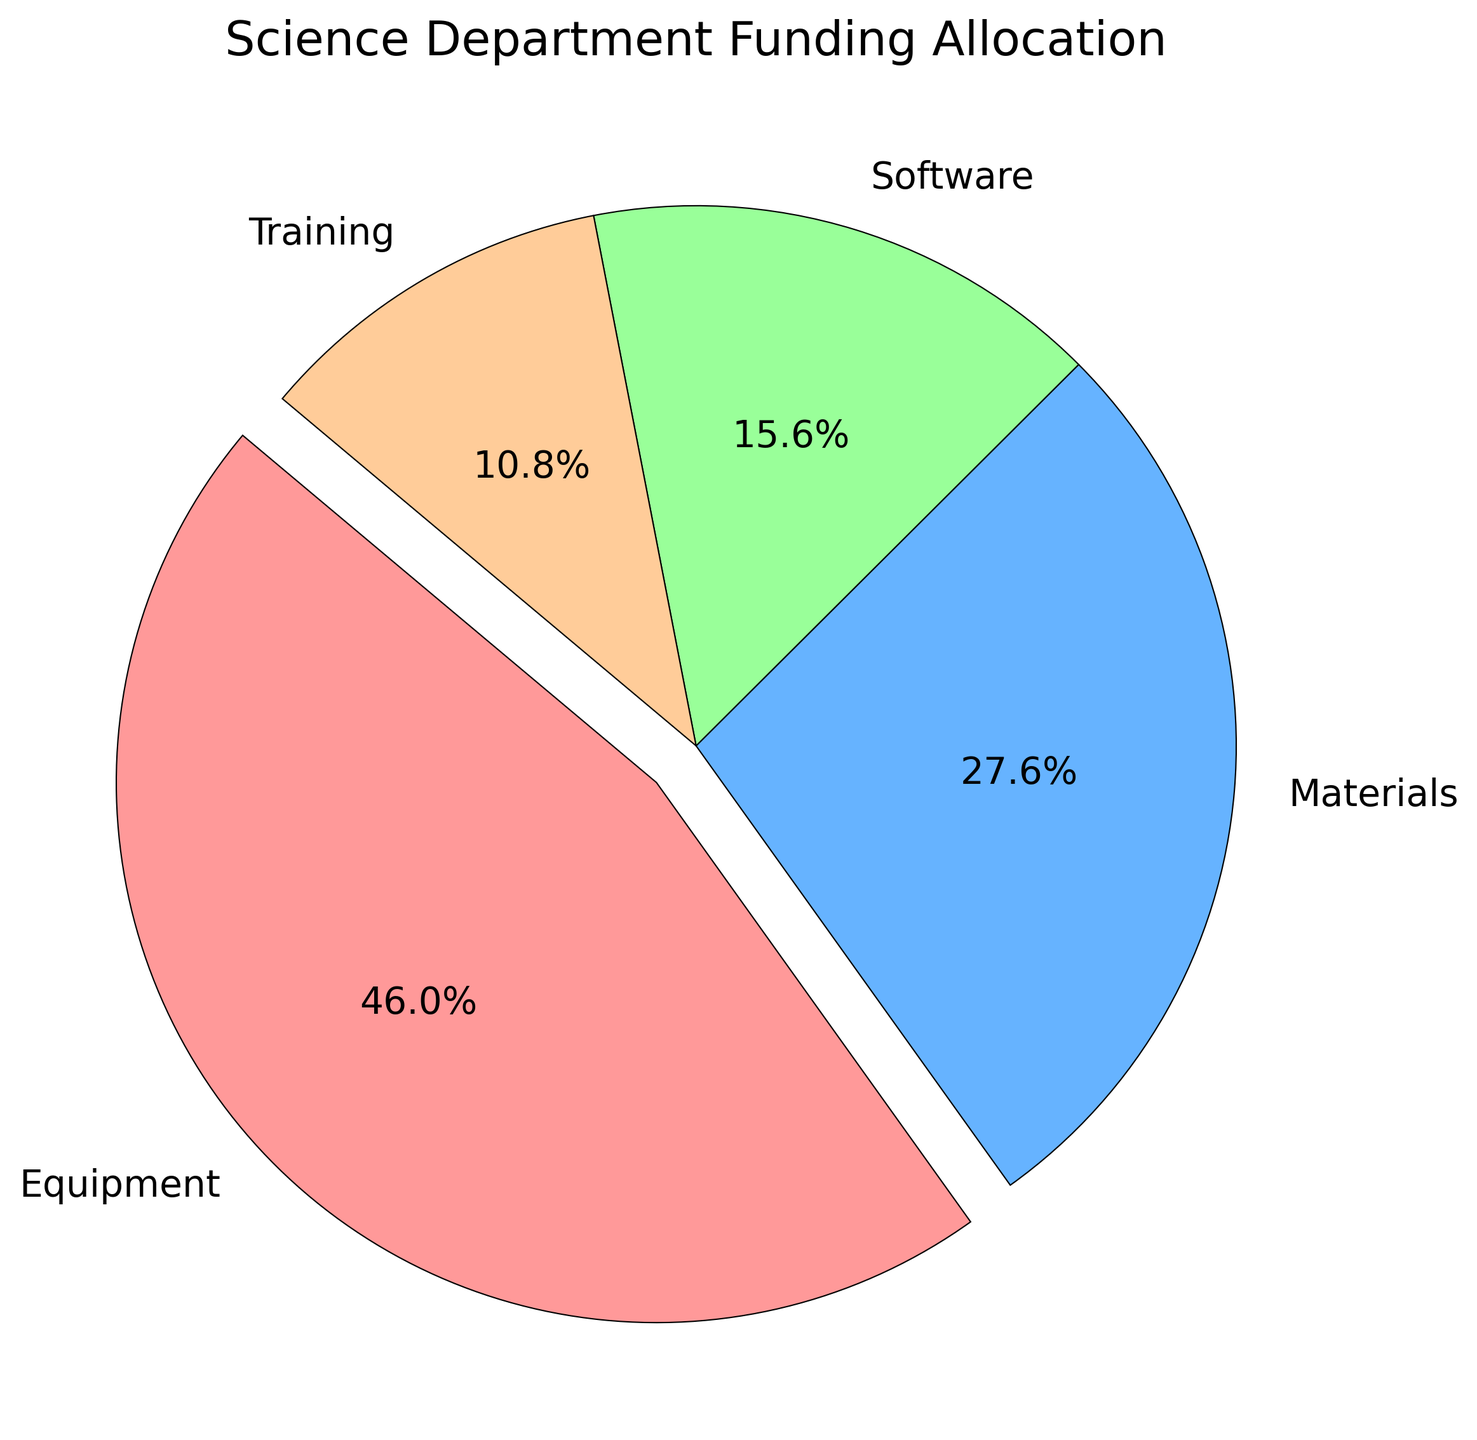Which category gets the largest allocation? Look at the slices of the pie chart and identify which one is the largest. The Equipment slice is the largest.
Answer: Equipment What percentage of the budget is assigned to software? Locate the Software slice on the pie chart and read the percentage label. The Software slice shows around 15.6%.
Answer: 15.6% How much more funding is given to equipment compared to materials? Observe the slices for Equipment and Materials. Calculate the difference using the total amounts: Equipment (245,000) and Materials (117,000). The difference is 245,000 - 117,000 = 128,000.
Answer: 128,000 Are training and software allocations nearly equal? Compare the slices of Training and Software. The Software slice is larger than the Training slice but not by a large margin. Training is around 12.2% and Software is around 15.6%.
Answer: No What colors represent the Materials and Training categories? Identify the corresponding slices and their colors. Materials are represented by an orange-like color and Training by a light green.
Answer: Orange, Light Green Which category has the smallest funding allocation? Look for the smallest slice in the pie chart. The Training slice is the smallest.
Answer: Training What is the combined percentage of funding for software and materials? Identify the percentages for Software and Materials from the pie chart, then add them together: Software (15.6%) + Materials (24.2%) = 39.8%.
Answer: 39.8% How does the funding for materials compare to the combined funding for software and training? Check the percentages on the pie chart for Materials, Software, and Training. Combined Software and Training percentages: 15.6% + 12.2% = 27.8%, Materials is 24.2%.
Answer: Materials get 2.4% less Which slice is exploded on the pie chart? An exploded slice is visually separated from the rest. The exploded slice is the Equipment slice.
Answer: Equipment What is the average amount of funding allocated to software across all entries? To find the average, sum the funding amounts for Software across all entries and divide by the number of entries: (15,000 + 18,000 + 16,000 + 17,000) / 4 = 16,500.
Answer: 16,500 